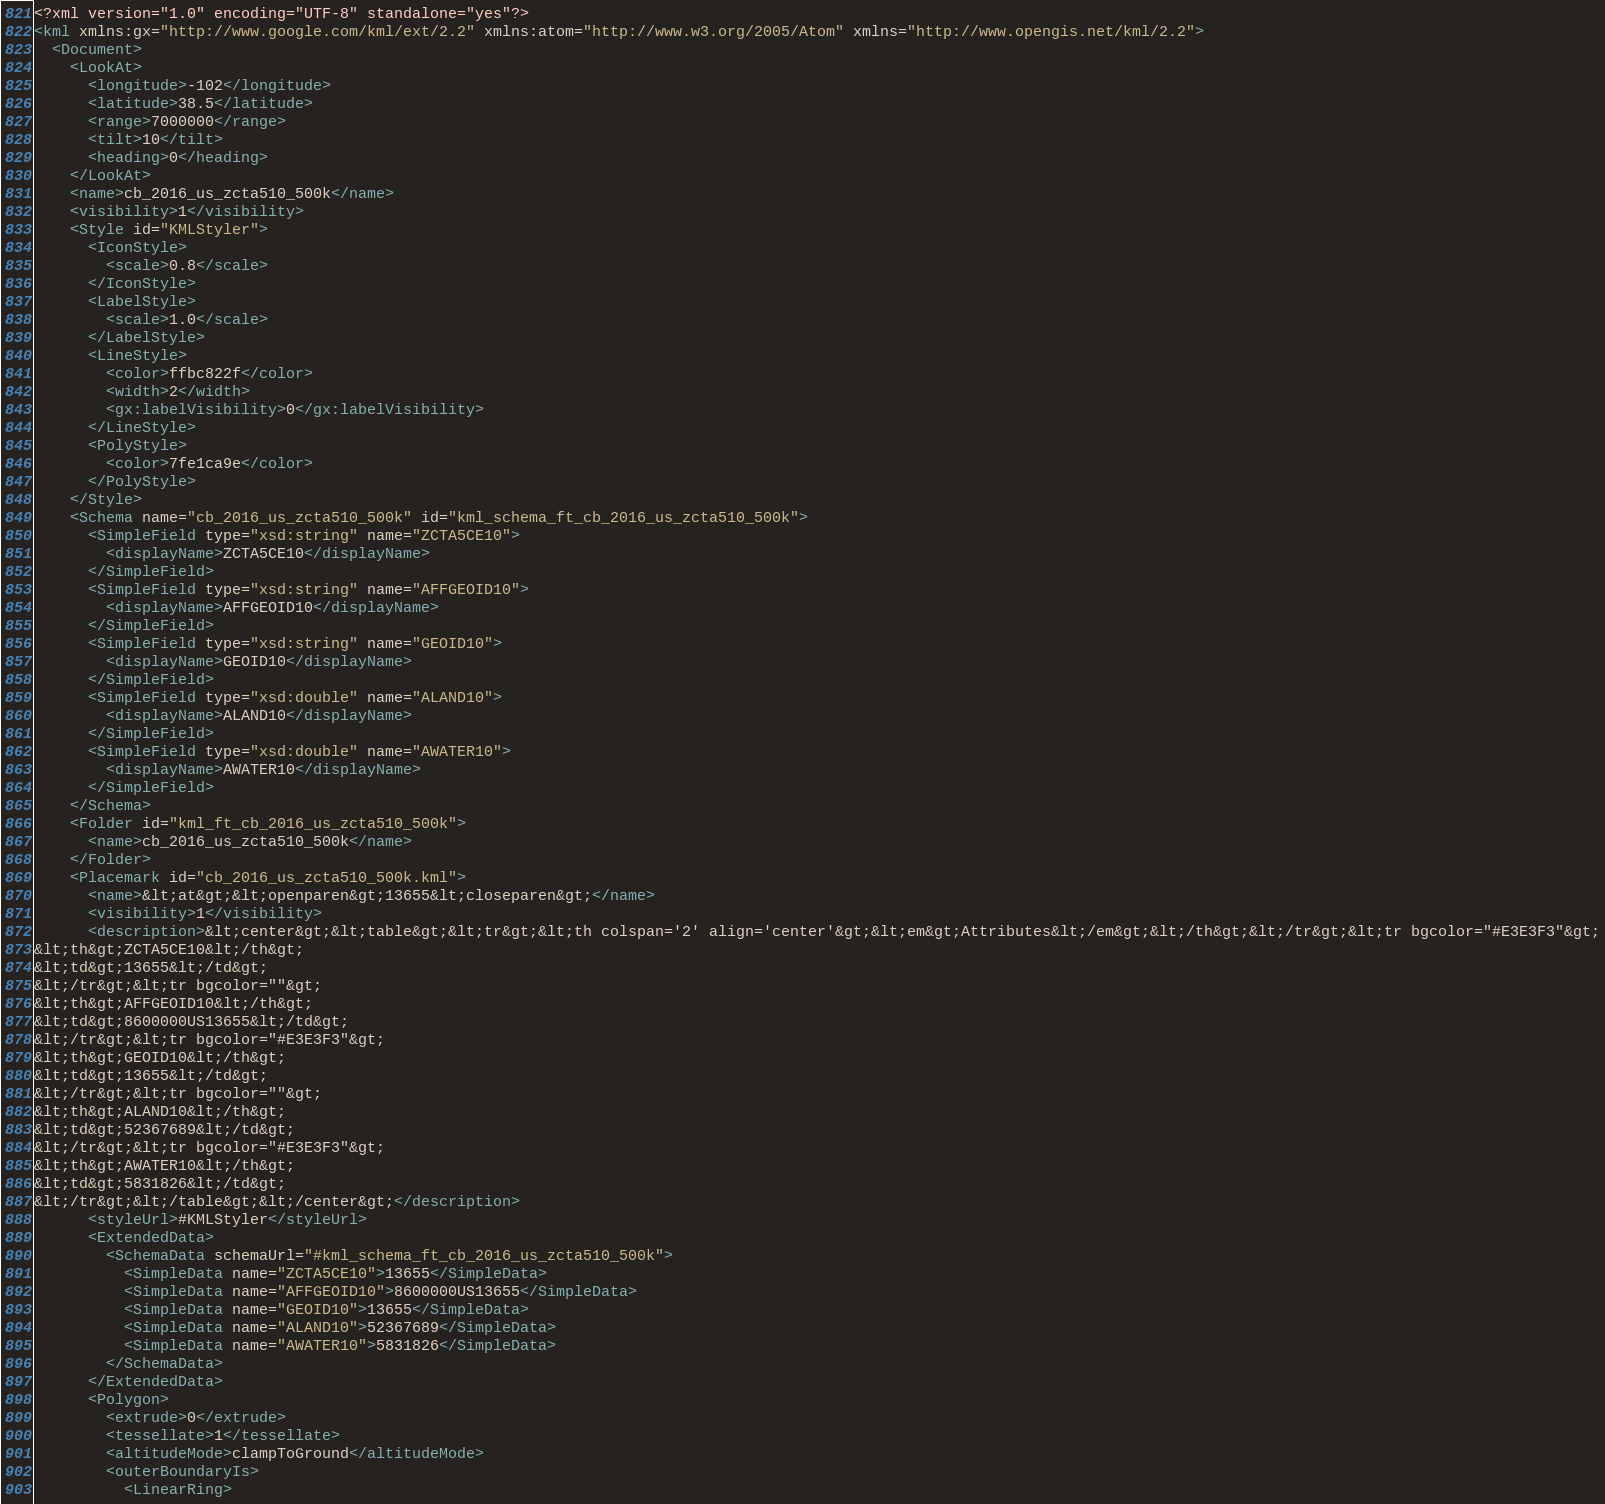Convert code to text. <code><loc_0><loc_0><loc_500><loc_500><_XML_><?xml version="1.0" encoding="UTF-8" standalone="yes"?>
<kml xmlns:gx="http://www.google.com/kml/ext/2.2" xmlns:atom="http://www.w3.org/2005/Atom" xmlns="http://www.opengis.net/kml/2.2">
  <Document>
    <LookAt>
      <longitude>-102</longitude>
      <latitude>38.5</latitude>
      <range>7000000</range>
      <tilt>10</tilt>
      <heading>0</heading>
    </LookAt>
    <name>cb_2016_us_zcta510_500k</name>
    <visibility>1</visibility>
    <Style id="KMLStyler">
      <IconStyle>
        <scale>0.8</scale>
      </IconStyle>
      <LabelStyle>
        <scale>1.0</scale>
      </LabelStyle>
      <LineStyle>
        <color>ffbc822f</color>
        <width>2</width>
        <gx:labelVisibility>0</gx:labelVisibility>
      </LineStyle>
      <PolyStyle>
        <color>7fe1ca9e</color>
      </PolyStyle>
    </Style>
    <Schema name="cb_2016_us_zcta510_500k" id="kml_schema_ft_cb_2016_us_zcta510_500k">
      <SimpleField type="xsd:string" name="ZCTA5CE10">
        <displayName>ZCTA5CE10</displayName>
      </SimpleField>
      <SimpleField type="xsd:string" name="AFFGEOID10">
        <displayName>AFFGEOID10</displayName>
      </SimpleField>
      <SimpleField type="xsd:string" name="GEOID10">
        <displayName>GEOID10</displayName>
      </SimpleField>
      <SimpleField type="xsd:double" name="ALAND10">
        <displayName>ALAND10</displayName>
      </SimpleField>
      <SimpleField type="xsd:double" name="AWATER10">
        <displayName>AWATER10</displayName>
      </SimpleField>
    </Schema>
    <Folder id="kml_ft_cb_2016_us_zcta510_500k">
      <name>cb_2016_us_zcta510_500k</name>
    </Folder>
    <Placemark id="cb_2016_us_zcta510_500k.kml">
      <name>&lt;at&gt;&lt;openparen&gt;13655&lt;closeparen&gt;</name>
      <visibility>1</visibility>
      <description>&lt;center&gt;&lt;table&gt;&lt;tr&gt;&lt;th colspan='2' align='center'&gt;&lt;em&gt;Attributes&lt;/em&gt;&lt;/th&gt;&lt;/tr&gt;&lt;tr bgcolor="#E3E3F3"&gt;
&lt;th&gt;ZCTA5CE10&lt;/th&gt;
&lt;td&gt;13655&lt;/td&gt;
&lt;/tr&gt;&lt;tr bgcolor=""&gt;
&lt;th&gt;AFFGEOID10&lt;/th&gt;
&lt;td&gt;8600000US13655&lt;/td&gt;
&lt;/tr&gt;&lt;tr bgcolor="#E3E3F3"&gt;
&lt;th&gt;GEOID10&lt;/th&gt;
&lt;td&gt;13655&lt;/td&gt;
&lt;/tr&gt;&lt;tr bgcolor=""&gt;
&lt;th&gt;ALAND10&lt;/th&gt;
&lt;td&gt;52367689&lt;/td&gt;
&lt;/tr&gt;&lt;tr bgcolor="#E3E3F3"&gt;
&lt;th&gt;AWATER10&lt;/th&gt;
&lt;td&gt;5831826&lt;/td&gt;
&lt;/tr&gt;&lt;/table&gt;&lt;/center&gt;</description>
      <styleUrl>#KMLStyler</styleUrl>
      <ExtendedData>
        <SchemaData schemaUrl="#kml_schema_ft_cb_2016_us_zcta510_500k">
          <SimpleData name="ZCTA5CE10">13655</SimpleData>
          <SimpleData name="AFFGEOID10">8600000US13655</SimpleData>
          <SimpleData name="GEOID10">13655</SimpleData>
          <SimpleData name="ALAND10">52367689</SimpleData>
          <SimpleData name="AWATER10">5831826</SimpleData>
        </SchemaData>
      </ExtendedData>
      <Polygon>
        <extrude>0</extrude>
        <tessellate>1</tessellate>
        <altitudeMode>clampToGround</altitudeMode>
        <outerBoundaryIs>
          <LinearRing></code> 